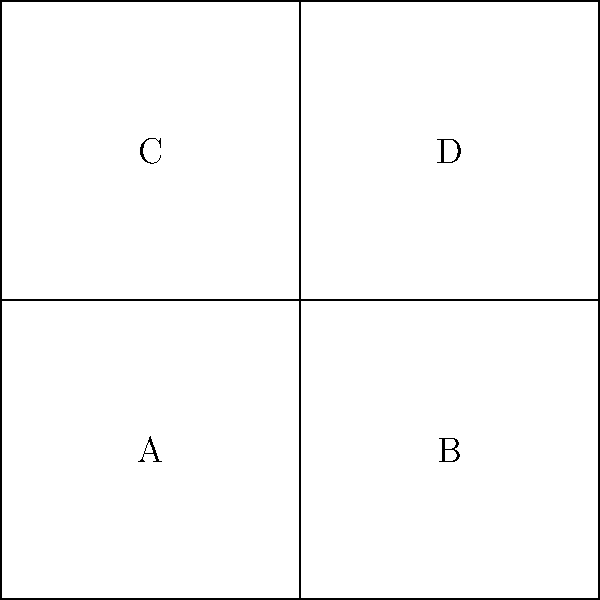Which 3D shape will be formed when this 2D net is folded along the dashed lines? How many faces will the resulting shape have? To determine the 3D shape and number of faces, let's follow these steps:

1. Identify the shape of each section:
   - We can see four equal squares labeled A, B, C, and D.

2. Visualize the folding process:
   - The net will fold along the dashed lines.
   - Squares A and C will form opposite faces.
   - Squares B and D will form opposite faces.

3. Determine the resulting 3D shape:
   - When folded, the four squares will form a cube.
   - A cube has six faces in total.

4. Count the faces:
   - We can see four faces in the net (A, B, C, D).
   - Two additional faces will be formed by the edges that meet when folded.

Therefore, the resulting 3D shape is a cube with 6 faces.
Answer: Cube, 6 faces 